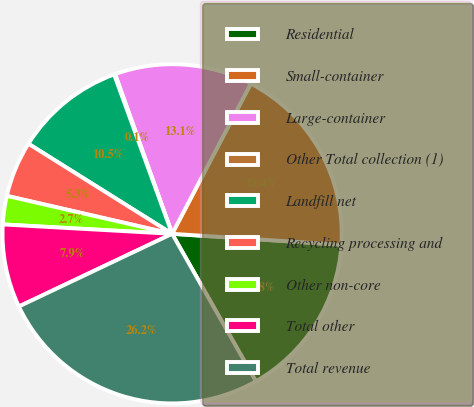Convert chart to OTSL. <chart><loc_0><loc_0><loc_500><loc_500><pie_chart><fcel>Residential<fcel>Small-container<fcel>Large-container<fcel>Other Total collection (1)<fcel>Landfill net<fcel>Recycling processing and<fcel>Other non-core<fcel>Total other<fcel>Total revenue<nl><fcel>15.75%<fcel>18.35%<fcel>13.14%<fcel>0.1%<fcel>10.53%<fcel>5.32%<fcel>2.71%<fcel>7.93%<fcel>26.17%<nl></chart> 